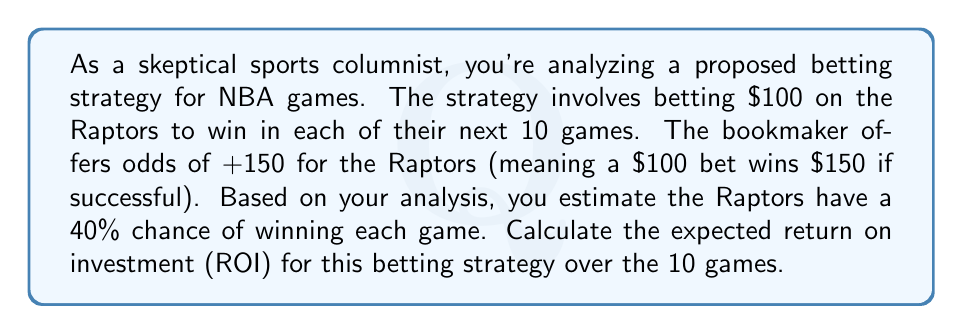Solve this math problem. Let's approach this step-by-step:

1) First, we need to calculate the expected value of each bet:

   Win scenario (40% chance):
   $EV_{win} = 0.40 \times ($150 + $100) = $100$

   Loss scenario (60% chance):
   $EV_{loss} = 0.60 \times (-$100) = -$60$

   Expected value per bet:
   $EV = EV_{win} + EV_{loss} = $100 - $60 = $40$

2) For 10 games, the total expected value is:
   $EV_{total} = 10 \times $40 = $400$

3) The total investment for 10 games is:
   $Investment = 10 \times $100 = $1000$

4) To calculate ROI, we use the formula:
   $ROI = \frac{Gain - Investment}{Investment} \times 100\%$

   Where Gain is the expected total return:
   $Gain = Investment + EV_{total} = $1000 + $400 = $1400$

5) Plugging into the ROI formula:
   $$ROI = \frac{$1400 - $1000}{$1000} \times 100\% = 0.40 \times 100\% = 40\%$$

Therefore, the expected ROI for this betting strategy over 10 games is 40%.
Answer: 40% 